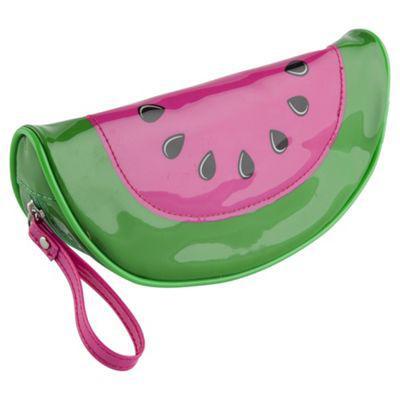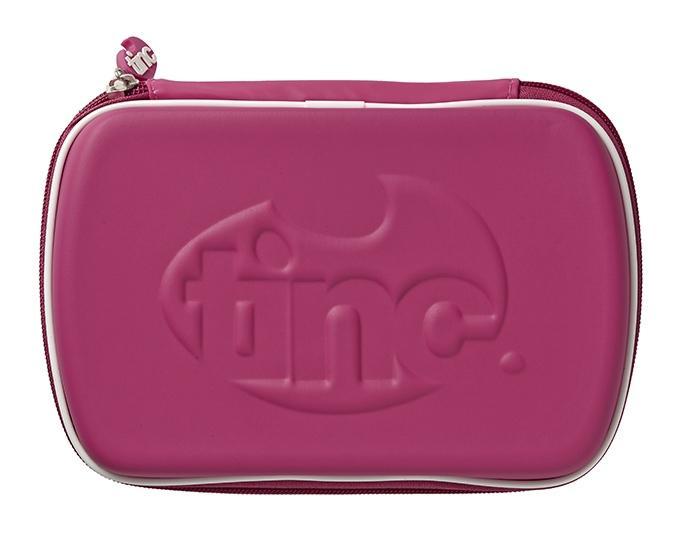The first image is the image on the left, the second image is the image on the right. Evaluate the accuracy of this statement regarding the images: "One of the cases looks like a watermelon slice with a turquoise-blue rind.". Is it true? Answer yes or no. No. The first image is the image on the left, the second image is the image on the right. Analyze the images presented: Is the assertion "The bag in the image on the left is shaped like a watermelon." valid? Answer yes or no. Yes. 